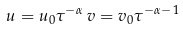<formula> <loc_0><loc_0><loc_500><loc_500>u = u _ { 0 } \tau ^ { - \alpha } \, v = v _ { 0 } \tau ^ { - \alpha - 1 }</formula> 